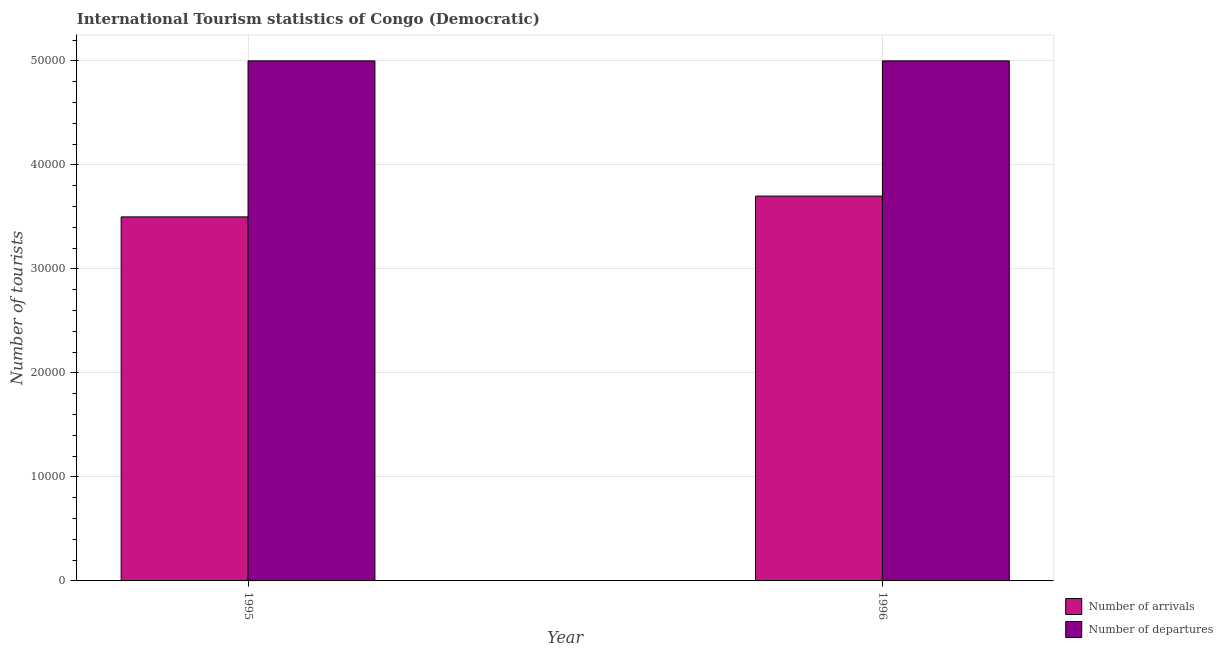How many groups of bars are there?
Your answer should be compact. 2. Are the number of bars per tick equal to the number of legend labels?
Provide a short and direct response. Yes. Are the number of bars on each tick of the X-axis equal?
Provide a succinct answer. Yes. How many bars are there on the 2nd tick from the left?
Your answer should be compact. 2. What is the label of the 1st group of bars from the left?
Provide a succinct answer. 1995. In how many cases, is the number of bars for a given year not equal to the number of legend labels?
Offer a terse response. 0. What is the number of tourist departures in 1995?
Make the answer very short. 5.00e+04. Across all years, what is the maximum number of tourist arrivals?
Keep it short and to the point. 3.70e+04. Across all years, what is the minimum number of tourist departures?
Provide a succinct answer. 5.00e+04. In which year was the number of tourist arrivals maximum?
Keep it short and to the point. 1996. In which year was the number of tourist departures minimum?
Provide a short and direct response. 1995. What is the total number of tourist departures in the graph?
Your answer should be very brief. 1.00e+05. What is the difference between the number of tourist arrivals in 1995 and that in 1996?
Offer a terse response. -2000. What is the difference between the number of tourist arrivals in 1996 and the number of tourist departures in 1995?
Provide a short and direct response. 2000. In the year 1995, what is the difference between the number of tourist departures and number of tourist arrivals?
Your answer should be compact. 0. In how many years, is the number of tourist departures greater than 12000?
Make the answer very short. 2. What is the ratio of the number of tourist arrivals in 1995 to that in 1996?
Your response must be concise. 0.95. In how many years, is the number of tourist departures greater than the average number of tourist departures taken over all years?
Your answer should be compact. 0. What does the 2nd bar from the left in 1995 represents?
Provide a succinct answer. Number of departures. What does the 1st bar from the right in 1995 represents?
Your response must be concise. Number of departures. How many years are there in the graph?
Provide a succinct answer. 2. Are the values on the major ticks of Y-axis written in scientific E-notation?
Offer a very short reply. No. Does the graph contain any zero values?
Provide a succinct answer. No. What is the title of the graph?
Your response must be concise. International Tourism statistics of Congo (Democratic). What is the label or title of the X-axis?
Keep it short and to the point. Year. What is the label or title of the Y-axis?
Offer a terse response. Number of tourists. What is the Number of tourists of Number of arrivals in 1995?
Your answer should be very brief. 3.50e+04. What is the Number of tourists in Number of arrivals in 1996?
Provide a succinct answer. 3.70e+04. Across all years, what is the maximum Number of tourists in Number of arrivals?
Ensure brevity in your answer.  3.70e+04. Across all years, what is the maximum Number of tourists of Number of departures?
Your response must be concise. 5.00e+04. Across all years, what is the minimum Number of tourists of Number of arrivals?
Provide a short and direct response. 3.50e+04. Across all years, what is the minimum Number of tourists in Number of departures?
Your answer should be compact. 5.00e+04. What is the total Number of tourists in Number of arrivals in the graph?
Your answer should be compact. 7.20e+04. What is the difference between the Number of tourists in Number of arrivals in 1995 and that in 1996?
Provide a short and direct response. -2000. What is the difference between the Number of tourists in Number of departures in 1995 and that in 1996?
Give a very brief answer. 0. What is the difference between the Number of tourists in Number of arrivals in 1995 and the Number of tourists in Number of departures in 1996?
Your answer should be very brief. -1.50e+04. What is the average Number of tourists in Number of arrivals per year?
Ensure brevity in your answer.  3.60e+04. In the year 1995, what is the difference between the Number of tourists in Number of arrivals and Number of tourists in Number of departures?
Provide a short and direct response. -1.50e+04. In the year 1996, what is the difference between the Number of tourists of Number of arrivals and Number of tourists of Number of departures?
Your answer should be very brief. -1.30e+04. What is the ratio of the Number of tourists of Number of arrivals in 1995 to that in 1996?
Offer a very short reply. 0.95. What is the difference between the highest and the second highest Number of tourists in Number of arrivals?
Ensure brevity in your answer.  2000. 